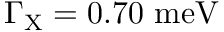Convert formula to latex. <formula><loc_0><loc_0><loc_500><loc_500>\Gamma _ { X } = 0 . 7 0 { m e V }</formula> 